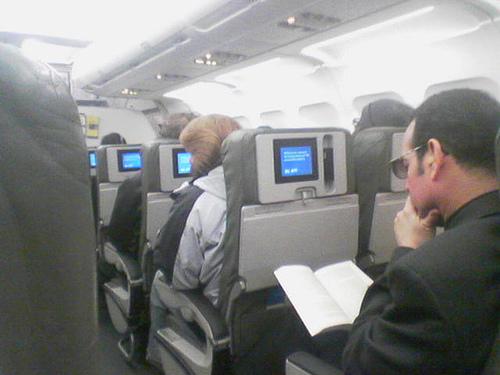Are the seats in an upright position?
Answer briefly. Yes. Are those people on a airplane?
Quick response, please. Yes. Is anything on the screens?
Quick response, please. Yes. 